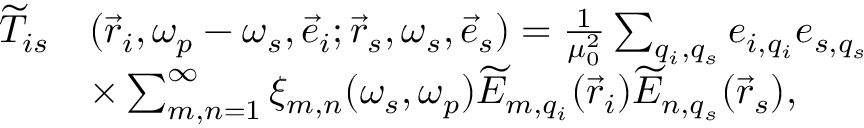Convert formula to latex. <formula><loc_0><loc_0><loc_500><loc_500>\begin{array} { r l } { \widetilde { T } _ { i s } } & { ( \vec { r } _ { i } , \omega _ { p } - \omega _ { s } , \vec { e } _ { i } ; \vec { r } _ { s } , \omega _ { s } , \vec { e } _ { s } ) = \frac { 1 } { \mu _ { 0 } ^ { 2 } } \sum _ { q _ { i } , q _ { s } } e _ { i , q _ { i } } e _ { s , q _ { s } } } \\ & { \times \sum _ { m , n = 1 } ^ { \infty } \xi _ { m , n } ( \omega _ { s } , \omega _ { p } ) \widetilde { E } _ { m , q _ { i } } ( \vec { r } _ { i } ) \widetilde { E } _ { n , q _ { s } } ( \vec { r } _ { s } ) , } \end{array}</formula> 